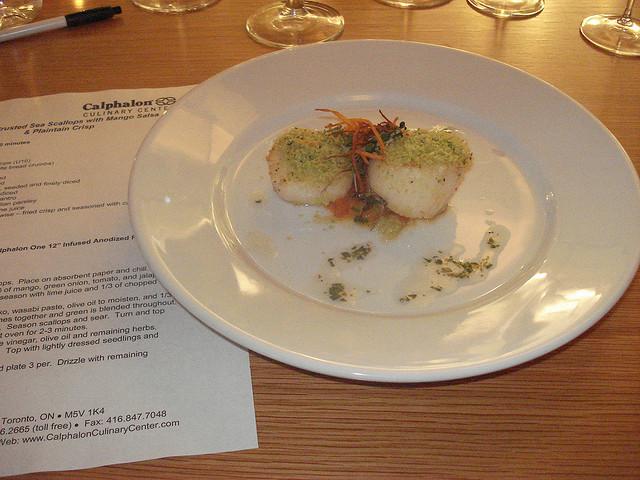IS this a formal or home cooked meal?
Concise answer only. Formal. Is this a gourmet meal?
Be succinct. Yes. What is the name of the culinary company on the document?
Keep it brief. Calphalon. 